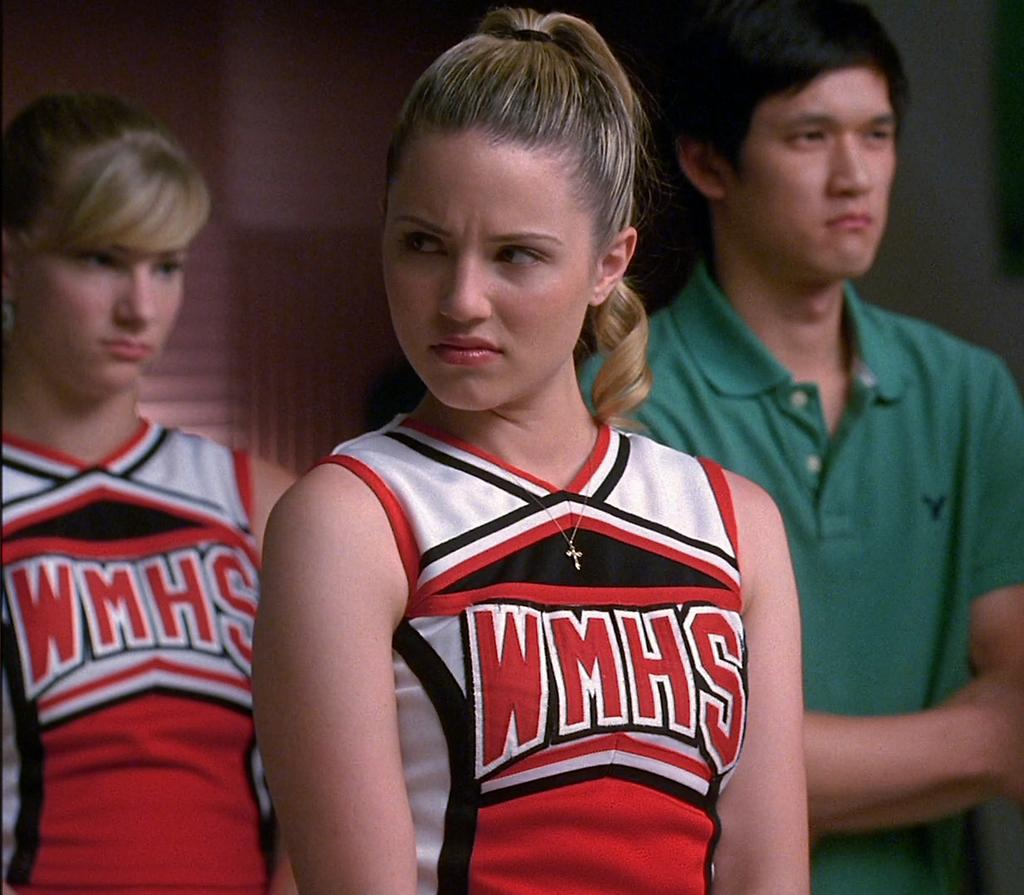<image>
Render a clear and concise summary of the photo. a lady that has WMHS on her jersey 